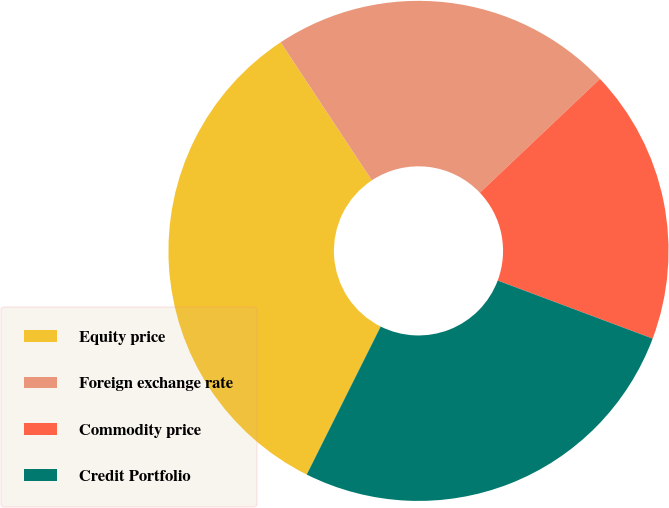Convert chart. <chart><loc_0><loc_0><loc_500><loc_500><pie_chart><fcel>Equity price<fcel>Foreign exchange rate<fcel>Commodity price<fcel>Credit Portfolio<nl><fcel>33.33%<fcel>22.22%<fcel>17.78%<fcel>26.67%<nl></chart> 